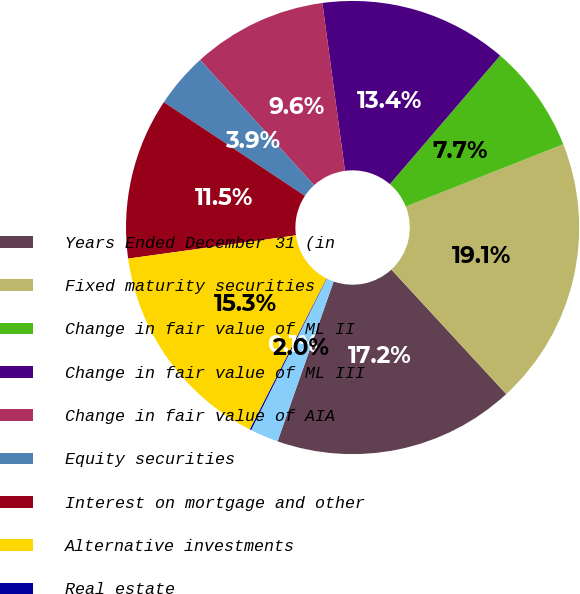Convert chart to OTSL. <chart><loc_0><loc_0><loc_500><loc_500><pie_chart><fcel>Years Ended December 31 (in<fcel>Fixed maturity securities<fcel>Change in fair value of ML II<fcel>Change in fair value of ML III<fcel>Change in fair value of AIA<fcel>Equity securities<fcel>Interest on mortgage and other<fcel>Alternative investments<fcel>Real estate<fcel>Other investments<nl><fcel>17.23%<fcel>19.13%<fcel>7.72%<fcel>13.42%<fcel>9.62%<fcel>3.92%<fcel>11.52%<fcel>15.32%<fcel>0.11%<fcel>2.01%<nl></chart> 